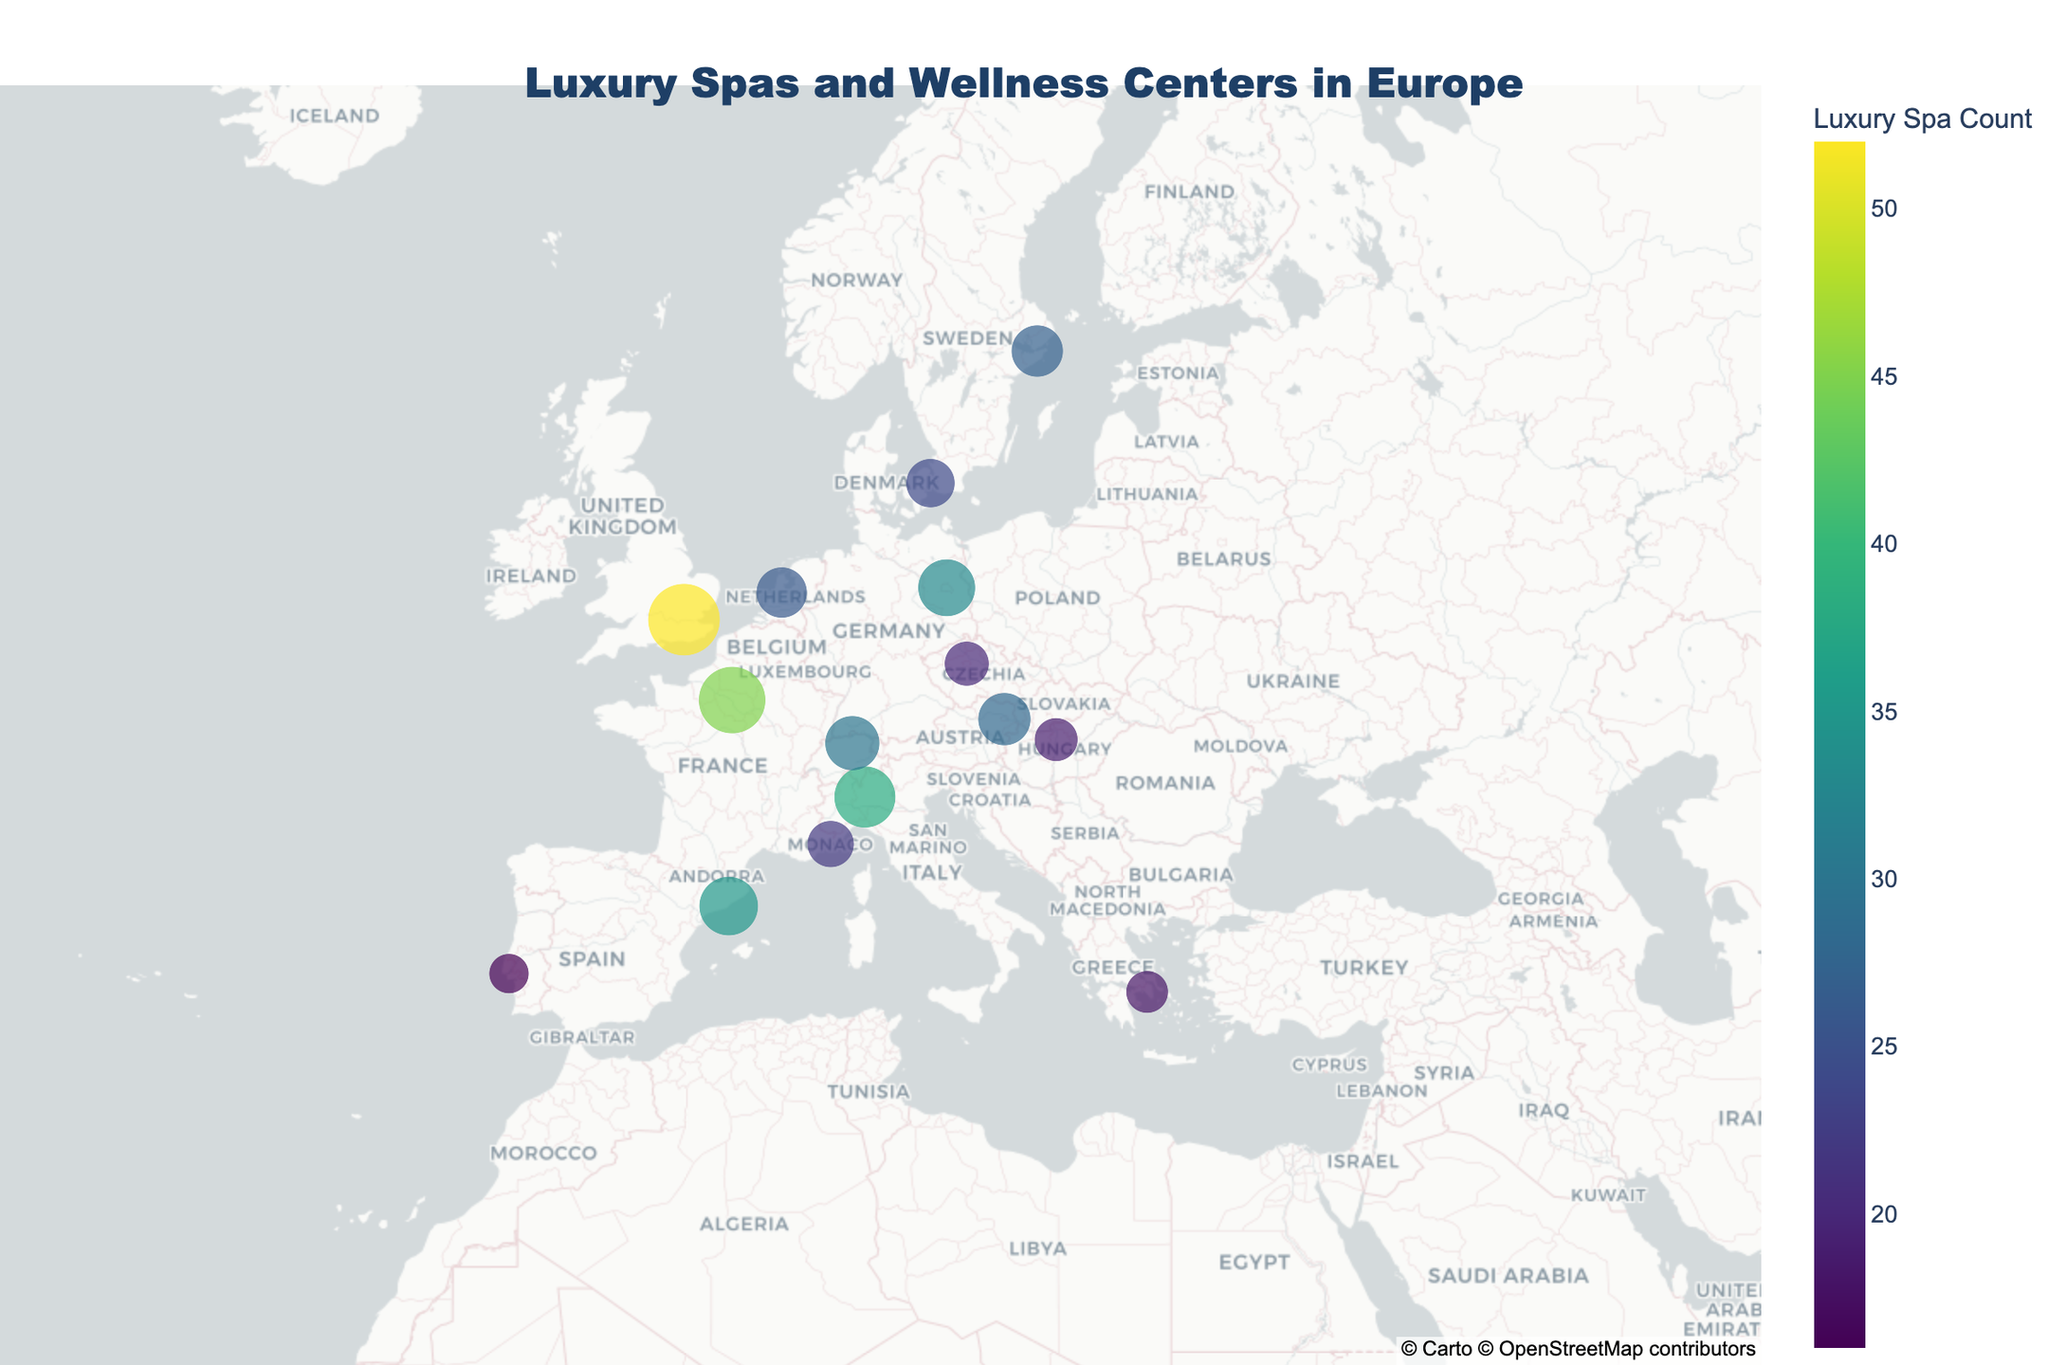Which city has the highest number of luxury spas and wellness centers? According to the figure, you can identify the city with the highest count by looking at the size and color of the markers which represent "Luxury Spa Count". The largest and darkest colored marker is in London.
Answer: London Which city has the lowest number of luxury spas and wellness centers? By observing the smallest and lightest colored marker on the map, you can determine the city with the lowest count. The smallest and lightest marker is in Lisbon.
Answer: Lisbon How many cities have more than 30 luxury spas and wellness centers? Identify the markers where the size and color indicate a count above 30. According to the figure, the cities with counts above 30 are Paris, Milan, London, and Barcelona.
Answer: 4 Which country is represented by the most markers on the map? Look at the hover data to see which country repeats the most across different cities. Based on the figure, Germany has markers in multiple cities. However, each city is unique here, so no country has more than one marker.
Answer: None What is the difference in the number of luxury spas between Paris and Athens? From the figure, the count for Paris is 45 and for Athens is 18. Calculate the difference by subtracting the count in Athens from the count in Paris: 45 - 18.
Answer: 27 Which city is closer in luxury spa count to Zurich: Berlin or Amsterdam? From the figure, Zurich has 30 spas, Berlin has 33 spas, and Amsterdam has 26 spas. Calculate the differences:
Answer: 3 (Berlin) What is the total number of luxury spas in the cities located in Italy, France, and Spain? Identify the cities in the mentioned countries, and sum their luxury spa counts. Milan (38, Italy), Paris (45, France), and Barcelona (35, Spain). Calculate the total: 38 + 45 + 35.
Answer: 118 Rank the cities from highest to lowest based on their luxury spa counts. By examining the size and color of the markers, the cities can be ranked as follows: London (52), Paris (45), Milan (38), Barcelona (35), Berlin (33), Zurich (30), Vienna (28), Stockholm (27), Amsterdam (26), Copenhagen (24), Monaco (22), Prague (20), Budapest (19), Athens (18), Lisbon (16).
Answer: London, Paris, Milan, Barcelona, Berlin, Zurich, Vienna, Stockholm, Amsterdam, Copenhagen, Monaco, Prague, Budapest, Athens, Lisbon How many cities have a luxury spa count less than 20? Identify the markers where the size and color indicate a count below 20. According to the figure, the cities are Prague, Athens, Lisbon, and Budapest.
Answer: 4 Comparing Zurich and Vienna, which city has a higher number of luxury spas and by how much? From the figure, Zurich has 30 luxury spas, and Vienna has 28. Calculate the difference: 30 - 28.
Answer: Zurich by 2 